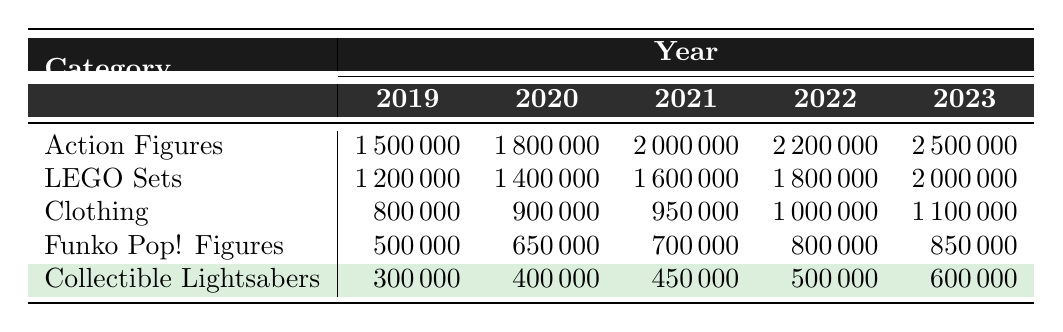What were the sales for LEGO Sets in 2021? In the table under the 'LEGO Sets' row and the '2021' column, the sales figure is listed as 1,600,000.
Answer: 1,600,000 Which category had the highest sales in 2022? Looking at the sales values for each category in the year 2022, 'Action Figures' had the highest sales figure of 2,200,000.
Answer: Action Figures How much did Clothing sales increase from 2019 to 2023? Clothing sales in 2019 were 800,000, while in 2023 they were 1,100,000. The increase is calculated as 1,100,000 - 800,000 = 300,000.
Answer: 300,000 What are the total sales for Funko Pop! Figures from 2019 to 2023? To find the total sales, add the sales figures for Funko Pop! Figures across all years: 500,000 + 650,000 + 700,000 + 800,000 + 850,000 = 3,500,000.
Answer: 3,500,000 Did the sales of Collectible Lightsabers ever exceed 500,000 dollars? Checking the sales figures for Collectible Lightsabers from 2019 to 2023 shows that the highest sales were 600,000 in 2023, so yes, it did exceed 500,000.
Answer: Yes What is the average sales figure for Action Figures across all years? The sales figures for Action Figures from 2019 to 2023 are 1,500,000; 1,800,000; 2,000,000; 2,200,000; and 2,500,000. Summing these gives 10,000,000, and dividing by 5 (the number of years) yields an average of 2,000,000.
Answer: 2,000,000 Which category had the least sales in 2020, and what was the amount? In 2020, the sales figures were: Action Figures 1,800,000, LEGO Sets 1,400,000, Clothing 900,000, Funko Pop! Figures 650,000, and Collectible Lightsabers 400,000. The least is for Collectible Lightsabers at 400,000.
Answer: Collectible Lightsabers, 400,000 What is the percentage growth of LEGO Sets sales from 2019 to 2023? The sales of LEGO Sets increased from 1,200,000 in 2019 to 2,000,000 in 2023. The growth can be calculated as (2,000,000 - 1,200,000) / 1,200,000 * 100% = 66.67%.
Answer: 66.67% Did all merchandise categories see an increase in sales from 2021 to 2022? Comparing sales figures, Action Figures increased from 2,000,000 to 2,200,000, LEGO Sets from 1,600,000 to 1,800,000, Clothing from 950,000 to 1,000,000, Funko Pop! Figures from 700,000 to 800,000, and Collectible Lightsabers from 450,000 to 500,000. All categories saw increases.
Answer: Yes What was the total sales for all categories combined in 2023? Adding the sales for all categories in 2023: 2,500,000 (Action Figures) + 2,000,000 (LEGO Sets) + 1,100,000 (Clothing) + 850,000 (Funko Pop! Figures) + 600,000 (Collectible Lightsabers) gives a total of 7,050,000.
Answer: 7,050,000 